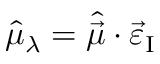<formula> <loc_0><loc_0><loc_500><loc_500>\hat { \mu } _ { \lambda } = \hat { \vec { \mu } } \cdot \vec { \varepsilon } _ { I }</formula> 